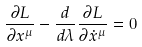Convert formula to latex. <formula><loc_0><loc_0><loc_500><loc_500>\frac { \partial L } { \partial x ^ { \mu } } - \frac { d } { d \lambda } \frac { \partial L } { \partial \dot { x } ^ { \mu } } = 0</formula> 